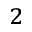<formula> <loc_0><loc_0><loc_500><loc_500>_ { 2 }</formula> 